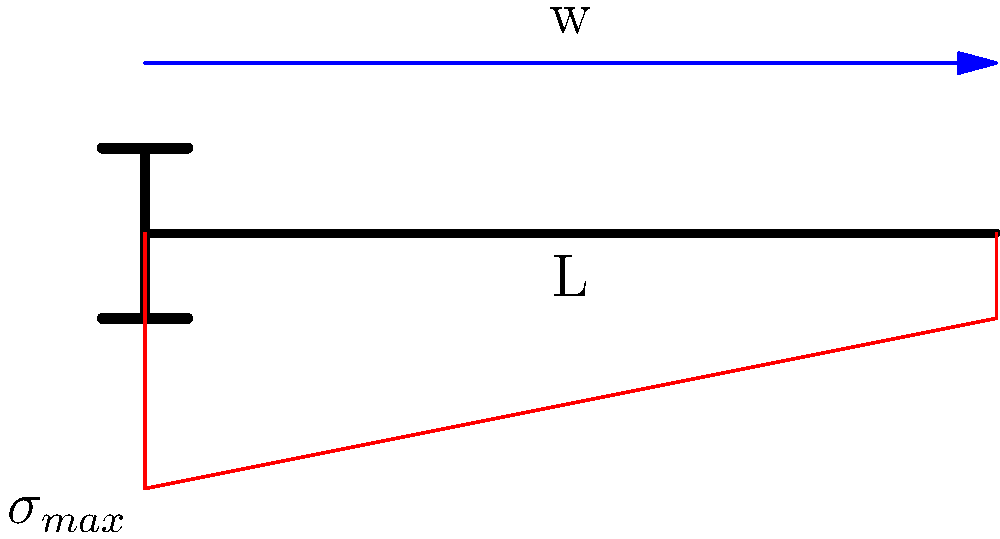A cantilever beam of length $L$ is subjected to a uniformly distributed load $w$ per unit length. If the beam has a rectangular cross-section with width $b$ and height $h$, determine the maximum bending stress $\sigma_{max}$ at the fixed end in terms of $w$, $L$, $b$, and $h$. To solve this problem, we'll follow these steps:

1) The maximum bending moment $M_{max}$ occurs at the fixed end of the cantilever beam. For a uniformly distributed load, it's given by:

   $$M_{max} = \frac{wL^2}{2}$$

2) The moment of inertia $I$ for a rectangular cross-section is:

   $$I = \frac{bh^3}{12}$$

3) The maximum stress in a beam occurs at the outermost fibers, where the distance from the neutral axis $y = h/2$. We can use the flexure formula:

   $$\sigma_{max} = \frac{My}{I}$$

4) Substituting the expressions for $M_{max}$, $y$, and $I$:

   $$\sigma_{max} = \frac{(\frac{wL^2}{2})(\frac{h}{2})}{\frac{bh^3}{12}}$$

5) Simplify:

   $$\sigma_{max} = \frac{6wL^2}{bh^2}$$

This expression gives the maximum bending stress at the fixed end of the cantilever beam in terms of the required parameters.
Answer: $\sigma_{max} = \frac{6wL^2}{bh^2}$ 